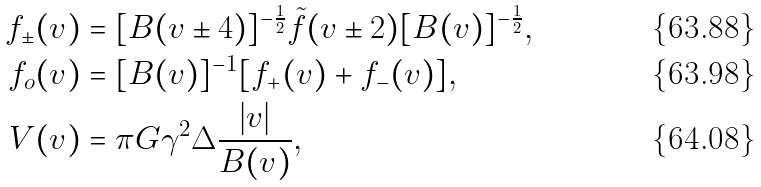Convert formula to latex. <formula><loc_0><loc_0><loc_500><loc_500>f _ { \pm } ( v ) & = [ B ( v \pm 4 ) ] ^ { - \frac { 1 } { 2 } } \tilde { f } ( v \pm 2 ) [ B ( v ) ] ^ { - \frac { 1 } { 2 } } , \\ f _ { o } ( v ) & = [ B ( v ) ] ^ { - 1 } [ f _ { + } ( v ) + f _ { - } ( v ) ] , \\ V ( v ) & = \pi G \gamma ^ { 2 } \Delta \frac { | v | } { B ( v ) } ,</formula> 